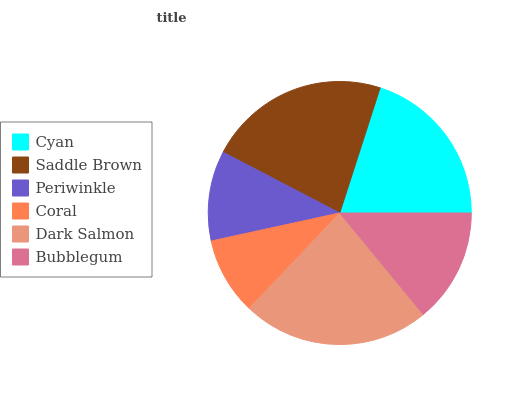Is Coral the minimum?
Answer yes or no. Yes. Is Dark Salmon the maximum?
Answer yes or no. Yes. Is Saddle Brown the minimum?
Answer yes or no. No. Is Saddle Brown the maximum?
Answer yes or no. No. Is Saddle Brown greater than Cyan?
Answer yes or no. Yes. Is Cyan less than Saddle Brown?
Answer yes or no. Yes. Is Cyan greater than Saddle Brown?
Answer yes or no. No. Is Saddle Brown less than Cyan?
Answer yes or no. No. Is Cyan the high median?
Answer yes or no. Yes. Is Bubblegum the low median?
Answer yes or no. Yes. Is Periwinkle the high median?
Answer yes or no. No. Is Dark Salmon the low median?
Answer yes or no. No. 